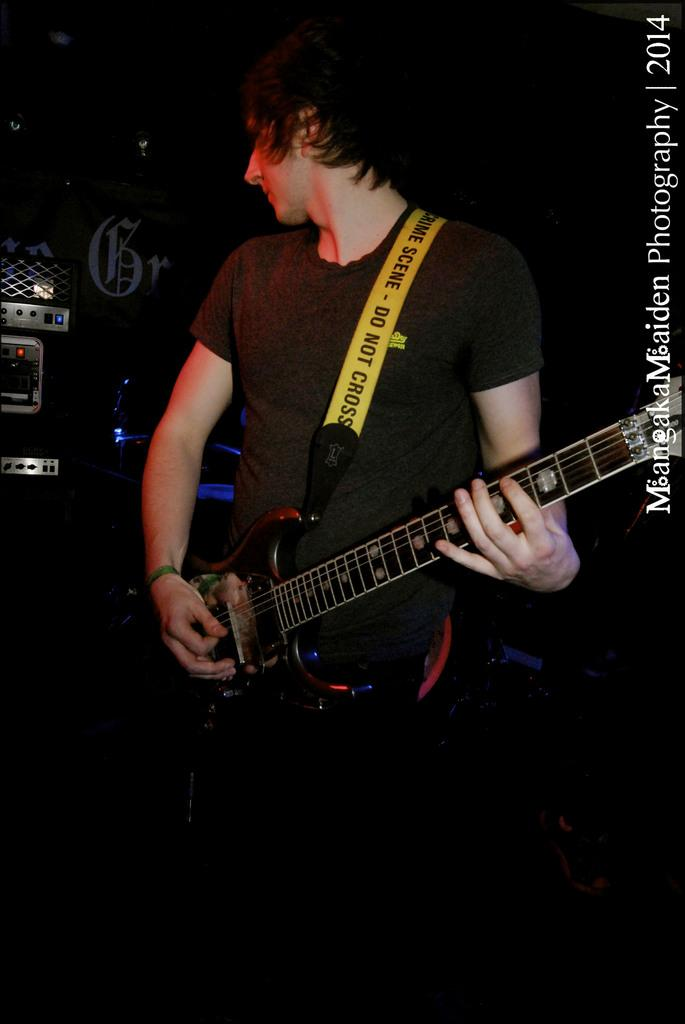What is the main subject of the image? There is a man in the image. What is the man doing in the image? The man is standing in the image. What object is the man holding in the image? The man is holding a guitar in his hand. How many chickens can be seen in the image? There are no chickens present in the image. What is the man's grandmother doing in the image? There is no mention of a grandmother in the image, and the man is the only person present. 